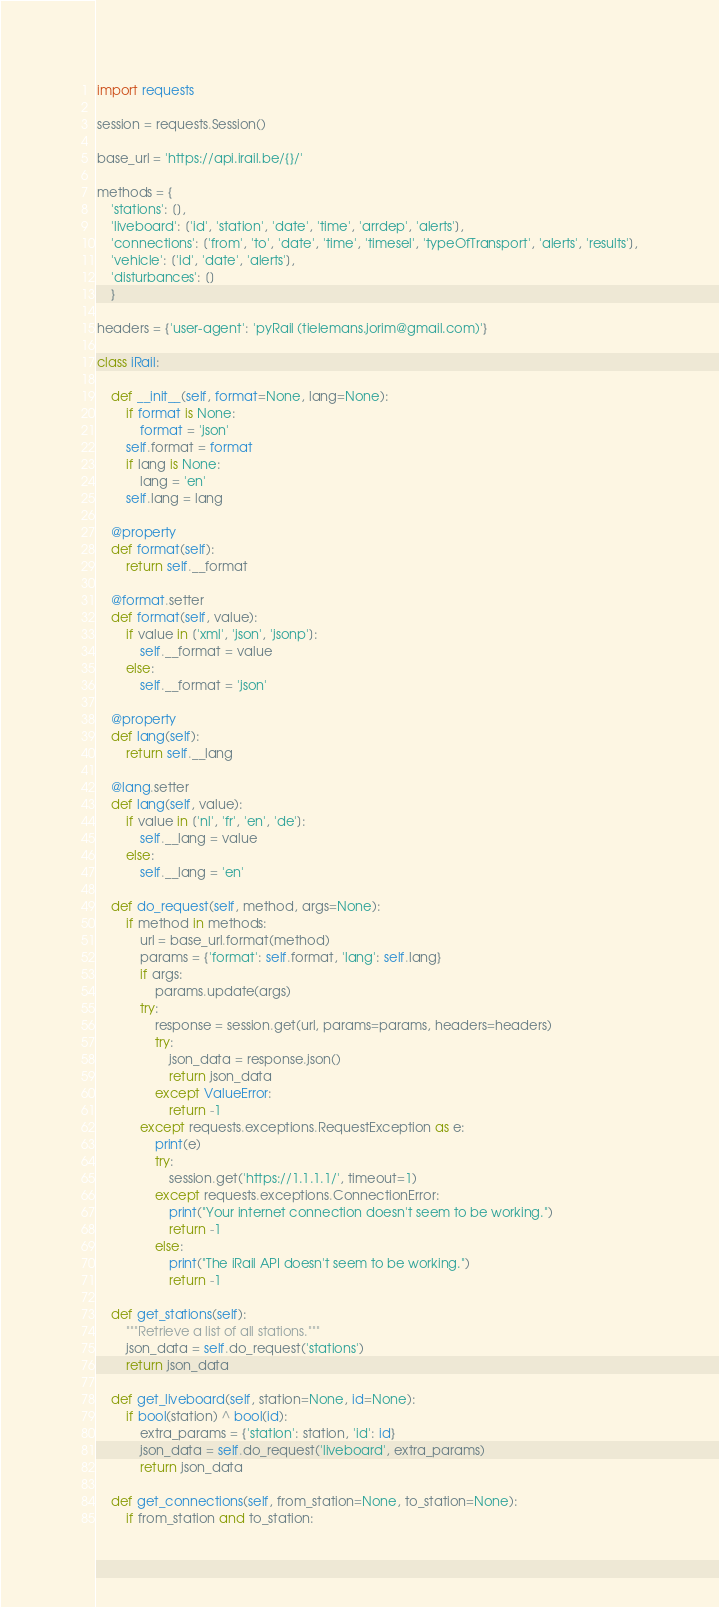Convert code to text. <code><loc_0><loc_0><loc_500><loc_500><_Python_>import requests

session = requests.Session()

base_url = 'https://api.irail.be/{}/'

methods = {
    'stations': [],
    'liveboard': ['id', 'station', 'date', 'time', 'arrdep', 'alerts'],
    'connections': ['from', 'to', 'date', 'time', 'timesel', 'typeOfTransport', 'alerts', 'results'],
    'vehicle': ['id', 'date', 'alerts'],
    'disturbances': []
    }

headers = {'user-agent': 'pyRail (tielemans.jorim@gmail.com)'}

class iRail:

    def __init__(self, format=None, lang=None):
        if format is None:
            format = 'json'
        self.format = format
        if lang is None:
            lang = 'en'
        self.lang = lang

    @property
    def format(self):
        return self.__format

    @format.setter
    def format(self, value):
        if value in ['xml', 'json', 'jsonp']:
            self.__format = value
        else:
            self.__format = 'json'

    @property
    def lang(self):
        return self.__lang

    @lang.setter
    def lang(self, value):
        if value in ['nl', 'fr', 'en', 'de']:
            self.__lang = value
        else:
            self.__lang = 'en'

    def do_request(self, method, args=None):
        if method in methods:
            url = base_url.format(method)
            params = {'format': self.format, 'lang': self.lang}
            if args:
                params.update(args)
            try:
                response = session.get(url, params=params, headers=headers)
                try:
                    json_data = response.json()
                    return json_data
                except ValueError:
                    return -1
            except requests.exceptions.RequestException as e:
                print(e)
                try:
                    session.get('https://1.1.1.1/', timeout=1)
                except requests.exceptions.ConnectionError:
                    print("Your internet connection doesn't seem to be working.")
                    return -1
                else:
                    print("The iRail API doesn't seem to be working.")
                    return -1

    def get_stations(self):
        """Retrieve a list of all stations."""
        json_data = self.do_request('stations')
        return json_data

    def get_liveboard(self, station=None, id=None):
        if bool(station) ^ bool(id):
            extra_params = {'station': station, 'id': id}
            json_data = self.do_request('liveboard', extra_params)
            return json_data

    def get_connections(self, from_station=None, to_station=None):
        if from_station and to_station:</code> 